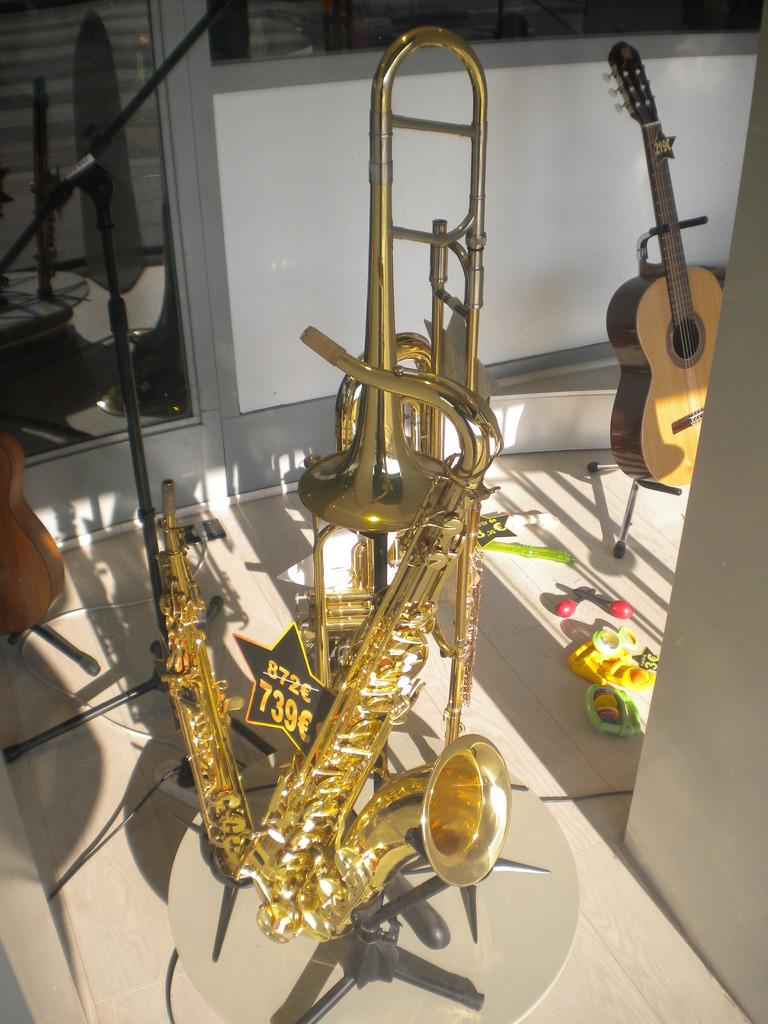What type of musical instruments are present in the image? There are saxophones, trombones, and guitars in the image. How are the musical instruments arranged in the image? The musical instruments are placed in a stand. What can be seen in the background of the image? There is a building and toys in the background of the image. Can you describe the dinosaurs playing the saxophones in the image? There are no dinosaurs present in the image, nor are there any dinosaurs playing saxophones. 